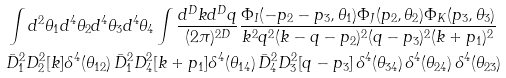<formula> <loc_0><loc_0><loc_500><loc_500>& \int d ^ { 2 } \theta _ { 1 } d ^ { 4 } \theta _ { 2 } d ^ { 4 } \theta _ { 3 } d ^ { 4 } \theta _ { 4 } \int \frac { d ^ { D } k d ^ { D } q } { ( 2 \pi ) ^ { 2 D } } \frac { \Phi _ { I } ( - p _ { 2 } - p _ { 3 } , \theta _ { 1 } ) \Phi _ { J } ( p _ { 2 } , \theta _ { 2 } ) \Phi _ { K } ( p _ { 3 } , \theta _ { 3 } ) } { k ^ { 2 } q ^ { 2 } ( k - q - p _ { 2 } ) ^ { 2 } ( q - p _ { 3 } ) ^ { 2 } ( k + p _ { 1 } ) ^ { 2 } } \\ & \bar { D } _ { 1 } ^ { 2 } D _ { 2 } ^ { 2 } [ k ] \delta ^ { 4 } ( \theta _ { 1 2 } ) \, \bar { D } _ { 1 } ^ { 2 } D _ { 4 } ^ { 2 } [ k + p _ { 1 } ] \delta ^ { 4 } ( \theta _ { 1 4 } ) \, \bar { D } _ { 4 } ^ { 2 } D _ { 3 } ^ { 2 } [ q - p _ { 3 } ] \, \delta ^ { 4 } ( \theta _ { 3 4 } ) \, \delta ^ { 4 } ( \theta _ { 2 4 } ) \, \delta ^ { 4 } ( \theta _ { 2 3 } ) \\</formula> 